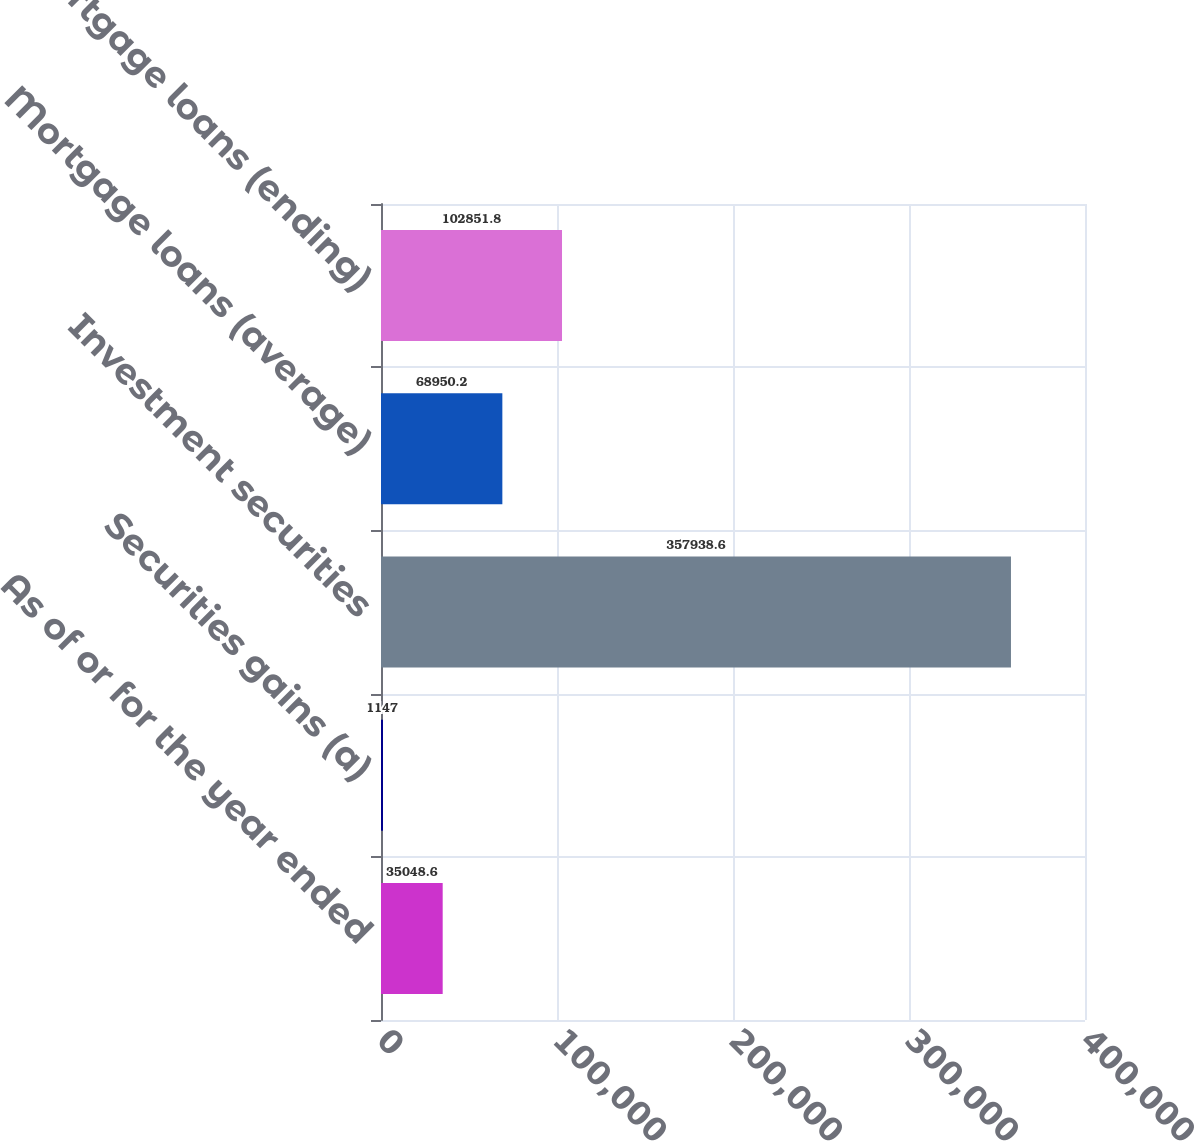<chart> <loc_0><loc_0><loc_500><loc_500><bar_chart><fcel>As of or for the year ended<fcel>Securities gains (a)<fcel>Investment securities<fcel>Mortgage loans (average)<fcel>Mortgage loans (ending)<nl><fcel>35048.6<fcel>1147<fcel>357939<fcel>68950.2<fcel>102852<nl></chart> 